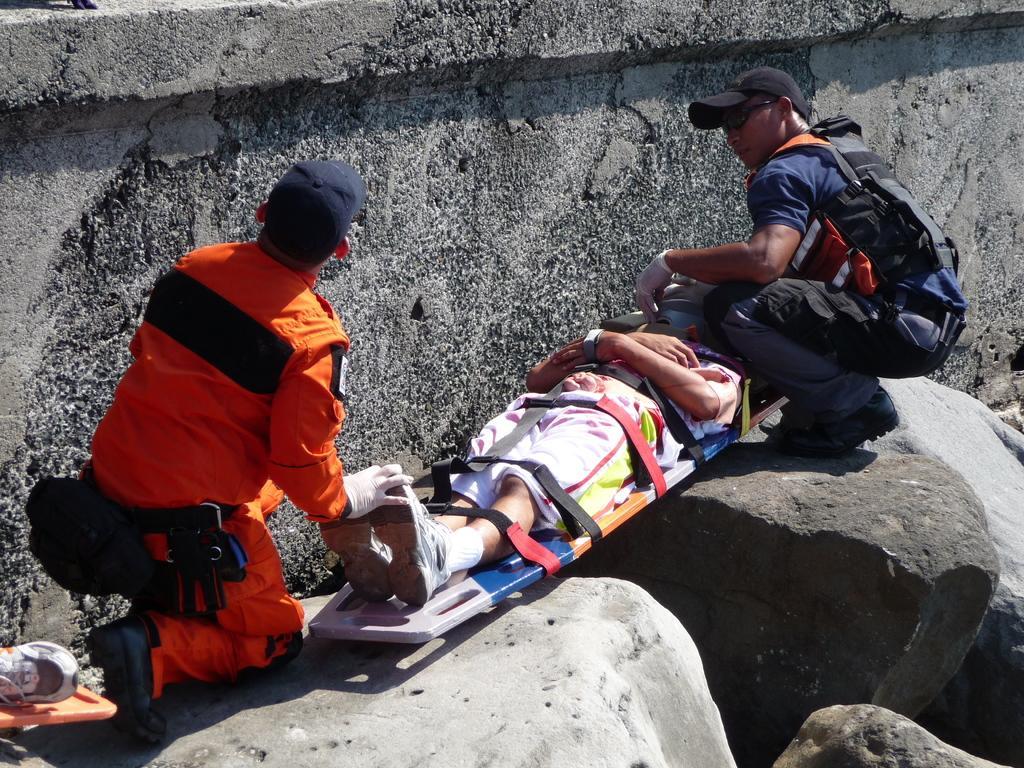In one or two sentences, can you explain what this image depicts? This picture is taken from the outside of the city. In this image, on the right side, we can see a man sitting in a squat position on the stone. On the left side, we can also see another person sitting on the stone. In the middle of the image, we can see a person lying on the stretcher and the person is also tied with some belts. In the background, we can see a wall. On the left side, we can also see a leg of a person. 